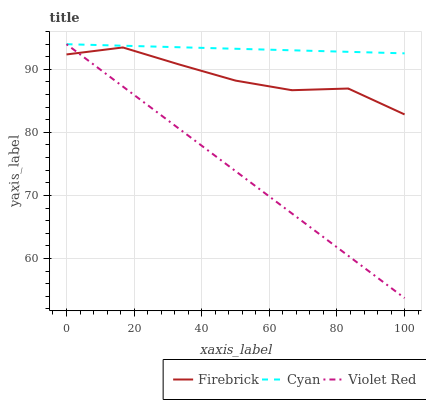Does Violet Red have the minimum area under the curve?
Answer yes or no. Yes. Does Cyan have the maximum area under the curve?
Answer yes or no. Yes. Does Firebrick have the minimum area under the curve?
Answer yes or no. No. Does Firebrick have the maximum area under the curve?
Answer yes or no. No. Is Violet Red the smoothest?
Answer yes or no. Yes. Is Firebrick the roughest?
Answer yes or no. Yes. Is Firebrick the smoothest?
Answer yes or no. No. Is Violet Red the roughest?
Answer yes or no. No. Does Violet Red have the lowest value?
Answer yes or no. Yes. Does Firebrick have the lowest value?
Answer yes or no. No. Does Violet Red have the highest value?
Answer yes or no. Yes. Does Firebrick have the highest value?
Answer yes or no. No. Is Firebrick less than Cyan?
Answer yes or no. Yes. Is Cyan greater than Firebrick?
Answer yes or no. Yes. Does Firebrick intersect Violet Red?
Answer yes or no. Yes. Is Firebrick less than Violet Red?
Answer yes or no. No. Is Firebrick greater than Violet Red?
Answer yes or no. No. Does Firebrick intersect Cyan?
Answer yes or no. No. 